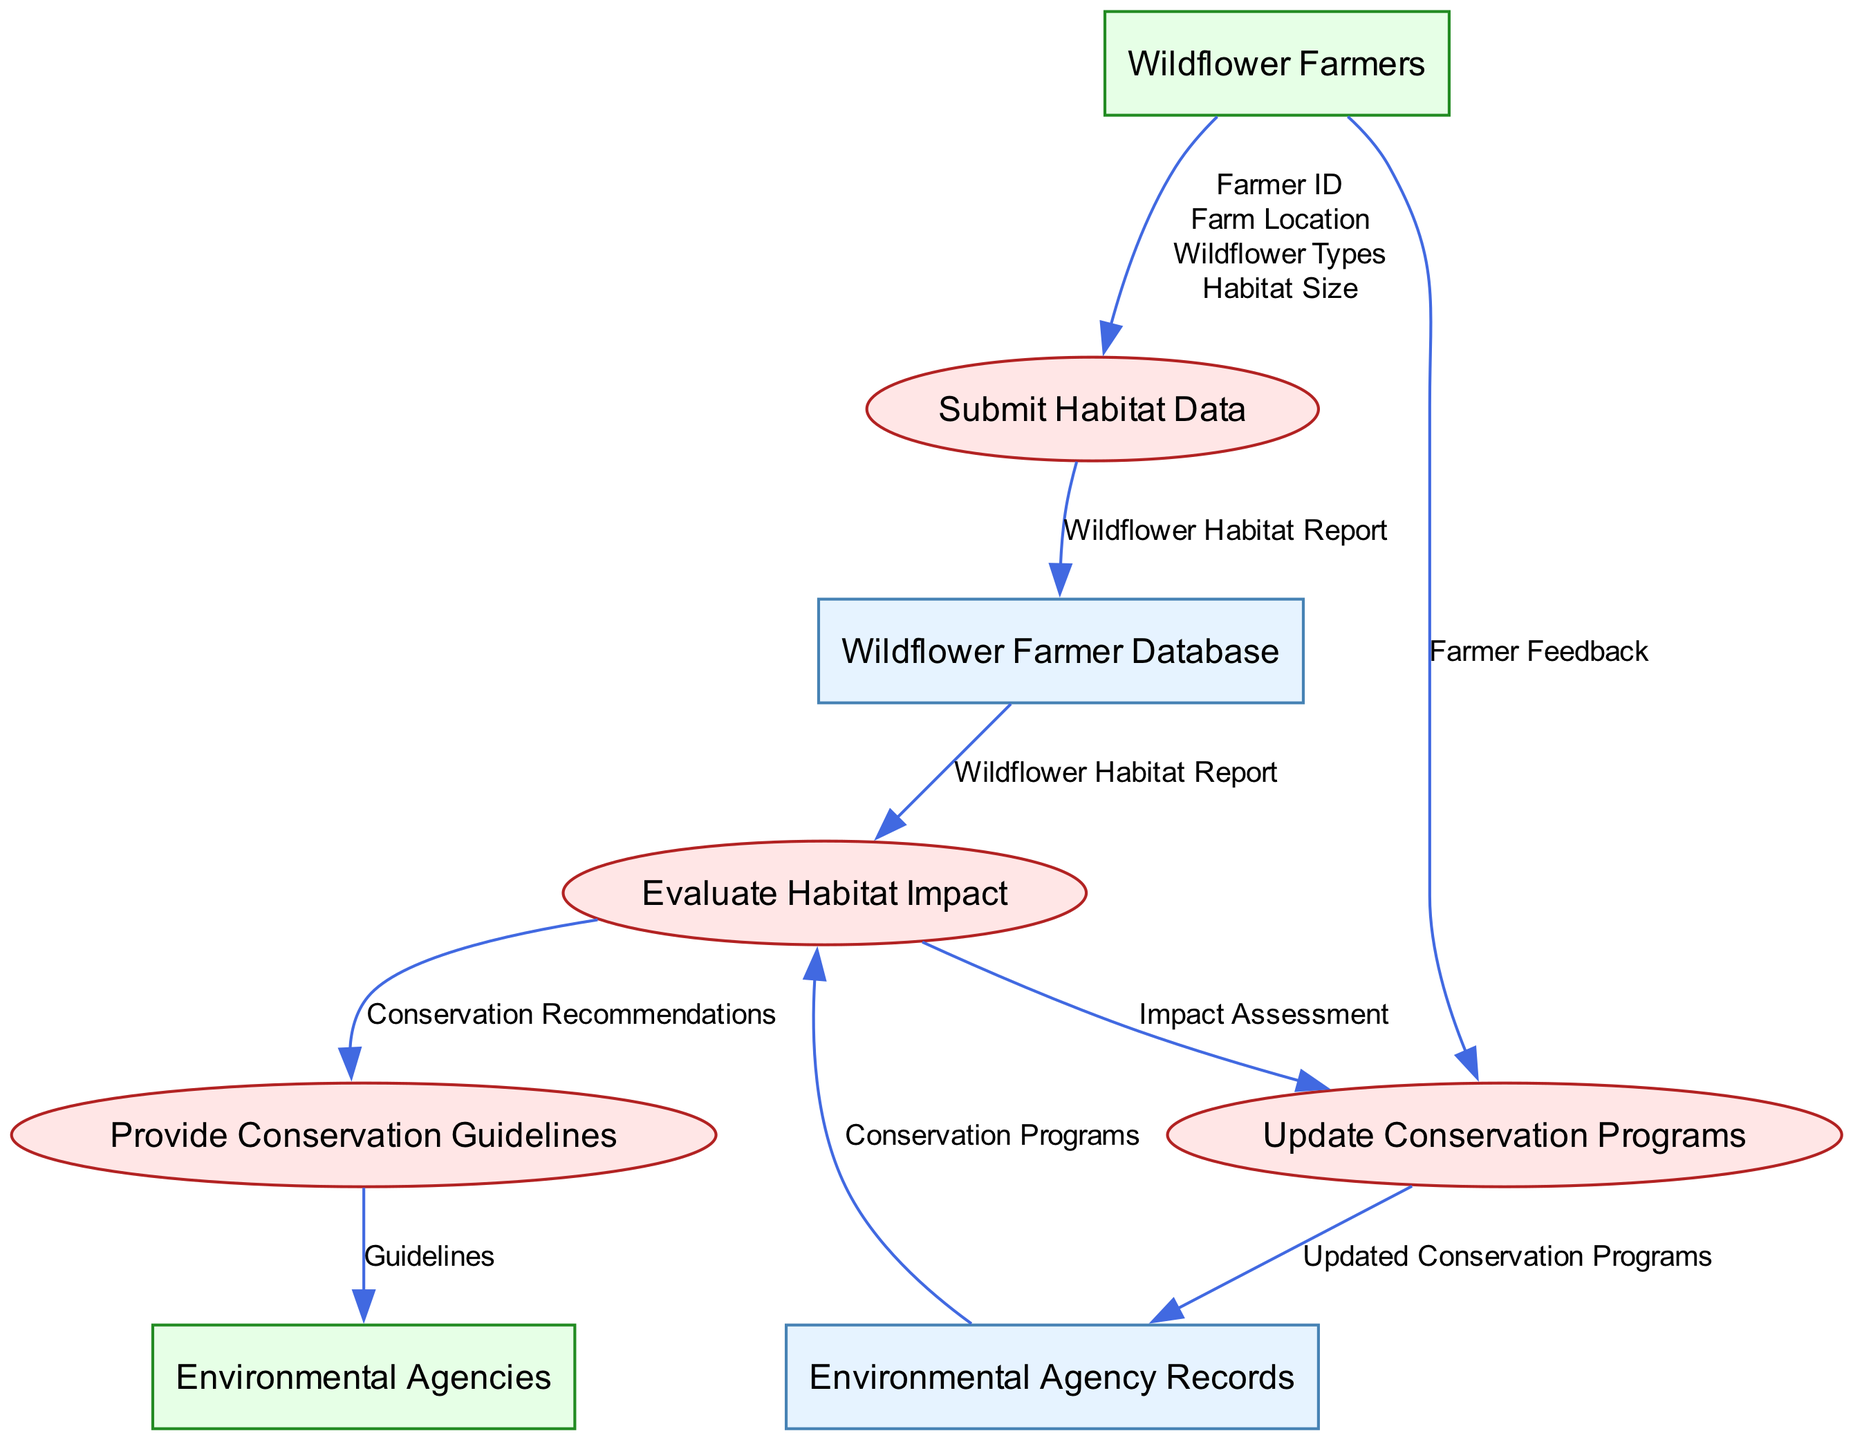What is the name of the first process in the diagram? The first process listed in the diagram is "Submit Habitat Data," which indicates that it is the initial step where wildflower farmers submit important information related to their farming practices.
Answer: Submit Habitat Data How many data stores are present in the diagram? There are two data stores shown in the diagram: "Wildflower Farmer Database" and "Environmental Agency Records." This is a straightforward count of the distinct data stores depicted.
Answer: 2 What type of report is generated in the "Submit Habitat Data" process? The output of the "Submit Habitat Data" process is labeled as "Wildflower Habitat Report," which signifies the type of information generated for further evaluation.
Answer: Wildflower Habitat Report Which process receives inputs from both "Wildflower Farmer Database" and "Environmental Agency Records"? The "Evaluate Habitat Impact" process receives inputs from both data stores, as indicated by the arrows leading to this process from each. This shows that it combines information from both sources for analysis.
Answer: Evaluate Habitat Impact What is the final output of the process "Update Conservation Programs"? The final output of the "Update Conservation Programs" process is "Updated Conservation Programs," indicating the result of this process.
Answer: Updated Conservation Programs What type of feedback do wildflower farmers provide in the diagram? The feedback provided by wildflower farmers is referred to simply as "Farmer Feedback," indicating that it could relate to any input or opinion regarding conservation programs or practices.
Answer: Farmer Feedback Which external entity receives the guidelines from the "Provide Conservation Guidelines" process? The "Provide Conservation Guidelines" process sends guidelines to the "Environmental Agencies," indicating the flow of essential information regarding conservation efforts.
Answer: Environmental Agencies How does the "Update Conservation Programs" process gather information? The "Update Conservation Programs" process gathers information from two sources: the "Impact Assessment" output from "Evaluate Habitat Impact" and "Farmer Feedback" from wildflower farmers, allowing it to update conservation strategies effectively.
Answer: Impact Assessment and Farmer Feedback What is the relationship between "Evaluate Habitat Impact" and "Provide Conservation Guidelines"? The relationship is that "Evaluate Habitat Impact" outputs "Conservation Recommendations," which are then used as inputs in the "Provide Conservation Guidelines" process, showing a clear flow of information from evaluation to guideline provision.
Answer: Conservation Recommendations 